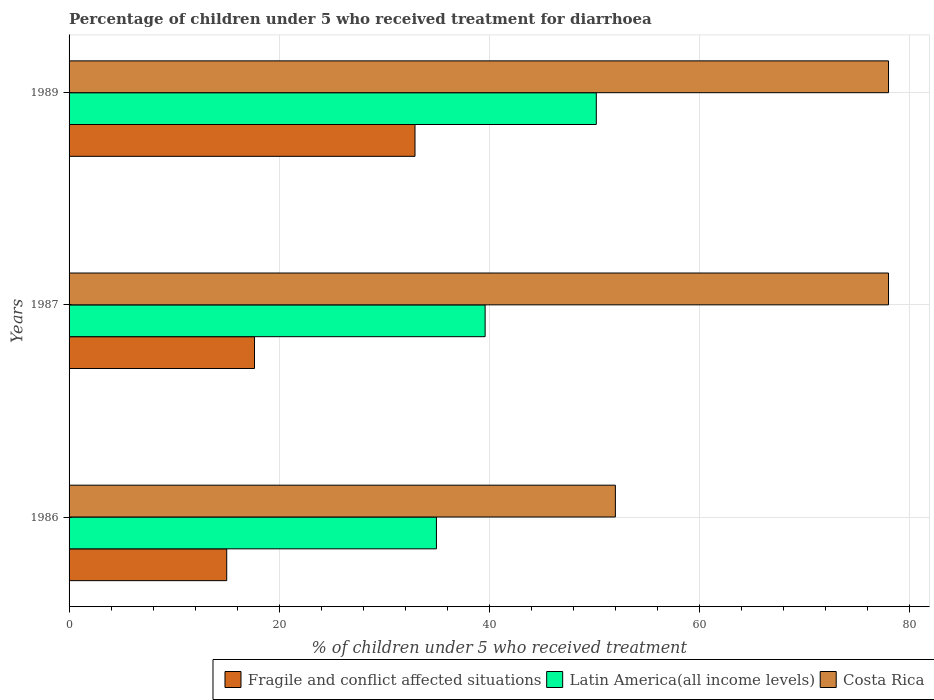How many different coloured bars are there?
Keep it short and to the point. 3. Are the number of bars on each tick of the Y-axis equal?
Give a very brief answer. Yes. How many bars are there on the 3rd tick from the top?
Make the answer very short. 3. How many bars are there on the 3rd tick from the bottom?
Provide a short and direct response. 3. What is the label of the 1st group of bars from the top?
Offer a terse response. 1989. In how many cases, is the number of bars for a given year not equal to the number of legend labels?
Keep it short and to the point. 0. What is the percentage of children who received treatment for diarrhoea  in Fragile and conflict affected situations in 1989?
Your answer should be very brief. 32.93. Across all years, what is the maximum percentage of children who received treatment for diarrhoea  in Fragile and conflict affected situations?
Ensure brevity in your answer.  32.93. Across all years, what is the minimum percentage of children who received treatment for diarrhoea  in Fragile and conflict affected situations?
Make the answer very short. 15.01. In which year was the percentage of children who received treatment for diarrhoea  in Costa Rica maximum?
Provide a short and direct response. 1987. In which year was the percentage of children who received treatment for diarrhoea  in Fragile and conflict affected situations minimum?
Give a very brief answer. 1986. What is the total percentage of children who received treatment for diarrhoea  in Fragile and conflict affected situations in the graph?
Offer a very short reply. 65.58. What is the difference between the percentage of children who received treatment for diarrhoea  in Costa Rica in 1987 and the percentage of children who received treatment for diarrhoea  in Fragile and conflict affected situations in 1989?
Provide a succinct answer. 45.07. What is the average percentage of children who received treatment for diarrhoea  in Latin America(all income levels) per year?
Provide a short and direct response. 41.59. In the year 1987, what is the difference between the percentage of children who received treatment for diarrhoea  in Latin America(all income levels) and percentage of children who received treatment for diarrhoea  in Fragile and conflict affected situations?
Make the answer very short. 21.95. In how many years, is the percentage of children who received treatment for diarrhoea  in Fragile and conflict affected situations greater than 56 %?
Provide a succinct answer. 0. What is the ratio of the percentage of children who received treatment for diarrhoea  in Fragile and conflict affected situations in 1987 to that in 1989?
Provide a succinct answer. 0.54. What is the difference between the highest and the second highest percentage of children who received treatment for diarrhoea  in Fragile and conflict affected situations?
Give a very brief answer. 15.28. What is the difference between the highest and the lowest percentage of children who received treatment for diarrhoea  in Fragile and conflict affected situations?
Ensure brevity in your answer.  17.92. In how many years, is the percentage of children who received treatment for diarrhoea  in Latin America(all income levels) greater than the average percentage of children who received treatment for diarrhoea  in Latin America(all income levels) taken over all years?
Your answer should be compact. 1. What does the 3rd bar from the top in 1987 represents?
Offer a terse response. Fragile and conflict affected situations. What does the 3rd bar from the bottom in 1986 represents?
Your answer should be very brief. Costa Rica. Is it the case that in every year, the sum of the percentage of children who received treatment for diarrhoea  in Latin America(all income levels) and percentage of children who received treatment for diarrhoea  in Costa Rica is greater than the percentage of children who received treatment for diarrhoea  in Fragile and conflict affected situations?
Give a very brief answer. Yes. What is the difference between two consecutive major ticks on the X-axis?
Provide a short and direct response. 20. Does the graph contain any zero values?
Make the answer very short. No. How are the legend labels stacked?
Ensure brevity in your answer.  Horizontal. What is the title of the graph?
Make the answer very short. Percentage of children under 5 who received treatment for diarrhoea. What is the label or title of the X-axis?
Your answer should be compact. % of children under 5 who received treatment. What is the label or title of the Y-axis?
Keep it short and to the point. Years. What is the % of children under 5 who received treatment of Fragile and conflict affected situations in 1986?
Provide a succinct answer. 15.01. What is the % of children under 5 who received treatment in Latin America(all income levels) in 1986?
Keep it short and to the point. 34.97. What is the % of children under 5 who received treatment in Costa Rica in 1986?
Keep it short and to the point. 52. What is the % of children under 5 who received treatment in Fragile and conflict affected situations in 1987?
Your response must be concise. 17.65. What is the % of children under 5 who received treatment in Latin America(all income levels) in 1987?
Ensure brevity in your answer.  39.6. What is the % of children under 5 who received treatment in Fragile and conflict affected situations in 1989?
Your answer should be compact. 32.93. What is the % of children under 5 who received treatment of Latin America(all income levels) in 1989?
Keep it short and to the point. 50.19. What is the % of children under 5 who received treatment in Costa Rica in 1989?
Give a very brief answer. 78. Across all years, what is the maximum % of children under 5 who received treatment in Fragile and conflict affected situations?
Your response must be concise. 32.93. Across all years, what is the maximum % of children under 5 who received treatment in Latin America(all income levels)?
Ensure brevity in your answer.  50.19. Across all years, what is the minimum % of children under 5 who received treatment of Fragile and conflict affected situations?
Your response must be concise. 15.01. Across all years, what is the minimum % of children under 5 who received treatment of Latin America(all income levels)?
Your answer should be very brief. 34.97. Across all years, what is the minimum % of children under 5 who received treatment in Costa Rica?
Give a very brief answer. 52. What is the total % of children under 5 who received treatment of Fragile and conflict affected situations in the graph?
Provide a short and direct response. 65.58. What is the total % of children under 5 who received treatment in Latin America(all income levels) in the graph?
Offer a very short reply. 124.76. What is the total % of children under 5 who received treatment of Costa Rica in the graph?
Keep it short and to the point. 208. What is the difference between the % of children under 5 who received treatment of Fragile and conflict affected situations in 1986 and that in 1987?
Offer a terse response. -2.64. What is the difference between the % of children under 5 who received treatment in Latin America(all income levels) in 1986 and that in 1987?
Your answer should be compact. -4.64. What is the difference between the % of children under 5 who received treatment in Fragile and conflict affected situations in 1986 and that in 1989?
Ensure brevity in your answer.  -17.92. What is the difference between the % of children under 5 who received treatment of Latin America(all income levels) in 1986 and that in 1989?
Your answer should be compact. -15.22. What is the difference between the % of children under 5 who received treatment of Fragile and conflict affected situations in 1987 and that in 1989?
Make the answer very short. -15.28. What is the difference between the % of children under 5 who received treatment of Latin America(all income levels) in 1987 and that in 1989?
Offer a very short reply. -10.58. What is the difference between the % of children under 5 who received treatment in Costa Rica in 1987 and that in 1989?
Make the answer very short. 0. What is the difference between the % of children under 5 who received treatment in Fragile and conflict affected situations in 1986 and the % of children under 5 who received treatment in Latin America(all income levels) in 1987?
Offer a very short reply. -24.6. What is the difference between the % of children under 5 who received treatment in Fragile and conflict affected situations in 1986 and the % of children under 5 who received treatment in Costa Rica in 1987?
Offer a very short reply. -62.99. What is the difference between the % of children under 5 who received treatment in Latin America(all income levels) in 1986 and the % of children under 5 who received treatment in Costa Rica in 1987?
Offer a very short reply. -43.03. What is the difference between the % of children under 5 who received treatment in Fragile and conflict affected situations in 1986 and the % of children under 5 who received treatment in Latin America(all income levels) in 1989?
Offer a terse response. -35.18. What is the difference between the % of children under 5 who received treatment in Fragile and conflict affected situations in 1986 and the % of children under 5 who received treatment in Costa Rica in 1989?
Give a very brief answer. -62.99. What is the difference between the % of children under 5 who received treatment in Latin America(all income levels) in 1986 and the % of children under 5 who received treatment in Costa Rica in 1989?
Your response must be concise. -43.03. What is the difference between the % of children under 5 who received treatment of Fragile and conflict affected situations in 1987 and the % of children under 5 who received treatment of Latin America(all income levels) in 1989?
Make the answer very short. -32.54. What is the difference between the % of children under 5 who received treatment in Fragile and conflict affected situations in 1987 and the % of children under 5 who received treatment in Costa Rica in 1989?
Provide a short and direct response. -60.35. What is the difference between the % of children under 5 who received treatment of Latin America(all income levels) in 1987 and the % of children under 5 who received treatment of Costa Rica in 1989?
Provide a succinct answer. -38.4. What is the average % of children under 5 who received treatment in Fragile and conflict affected situations per year?
Your answer should be compact. 21.86. What is the average % of children under 5 who received treatment of Latin America(all income levels) per year?
Keep it short and to the point. 41.59. What is the average % of children under 5 who received treatment of Costa Rica per year?
Offer a very short reply. 69.33. In the year 1986, what is the difference between the % of children under 5 who received treatment in Fragile and conflict affected situations and % of children under 5 who received treatment in Latin America(all income levels)?
Offer a terse response. -19.96. In the year 1986, what is the difference between the % of children under 5 who received treatment in Fragile and conflict affected situations and % of children under 5 who received treatment in Costa Rica?
Provide a short and direct response. -36.99. In the year 1986, what is the difference between the % of children under 5 who received treatment of Latin America(all income levels) and % of children under 5 who received treatment of Costa Rica?
Your response must be concise. -17.03. In the year 1987, what is the difference between the % of children under 5 who received treatment of Fragile and conflict affected situations and % of children under 5 who received treatment of Latin America(all income levels)?
Make the answer very short. -21.95. In the year 1987, what is the difference between the % of children under 5 who received treatment in Fragile and conflict affected situations and % of children under 5 who received treatment in Costa Rica?
Offer a very short reply. -60.35. In the year 1987, what is the difference between the % of children under 5 who received treatment in Latin America(all income levels) and % of children under 5 who received treatment in Costa Rica?
Your response must be concise. -38.4. In the year 1989, what is the difference between the % of children under 5 who received treatment in Fragile and conflict affected situations and % of children under 5 who received treatment in Latin America(all income levels)?
Offer a very short reply. -17.26. In the year 1989, what is the difference between the % of children under 5 who received treatment of Fragile and conflict affected situations and % of children under 5 who received treatment of Costa Rica?
Give a very brief answer. -45.07. In the year 1989, what is the difference between the % of children under 5 who received treatment in Latin America(all income levels) and % of children under 5 who received treatment in Costa Rica?
Your response must be concise. -27.81. What is the ratio of the % of children under 5 who received treatment in Fragile and conflict affected situations in 1986 to that in 1987?
Provide a succinct answer. 0.85. What is the ratio of the % of children under 5 who received treatment of Latin America(all income levels) in 1986 to that in 1987?
Your response must be concise. 0.88. What is the ratio of the % of children under 5 who received treatment in Fragile and conflict affected situations in 1986 to that in 1989?
Make the answer very short. 0.46. What is the ratio of the % of children under 5 who received treatment of Latin America(all income levels) in 1986 to that in 1989?
Provide a succinct answer. 0.7. What is the ratio of the % of children under 5 who received treatment of Costa Rica in 1986 to that in 1989?
Offer a terse response. 0.67. What is the ratio of the % of children under 5 who received treatment of Fragile and conflict affected situations in 1987 to that in 1989?
Make the answer very short. 0.54. What is the ratio of the % of children under 5 who received treatment in Latin America(all income levels) in 1987 to that in 1989?
Your response must be concise. 0.79. What is the difference between the highest and the second highest % of children under 5 who received treatment in Fragile and conflict affected situations?
Your answer should be compact. 15.28. What is the difference between the highest and the second highest % of children under 5 who received treatment of Latin America(all income levels)?
Make the answer very short. 10.58. What is the difference between the highest and the second highest % of children under 5 who received treatment in Costa Rica?
Keep it short and to the point. 0. What is the difference between the highest and the lowest % of children under 5 who received treatment in Fragile and conflict affected situations?
Offer a very short reply. 17.92. What is the difference between the highest and the lowest % of children under 5 who received treatment in Latin America(all income levels)?
Give a very brief answer. 15.22. What is the difference between the highest and the lowest % of children under 5 who received treatment of Costa Rica?
Keep it short and to the point. 26. 